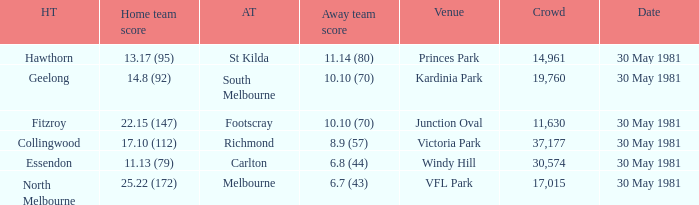What is the home venue of essendon with a crowd larger than 19,760? Windy Hill. 